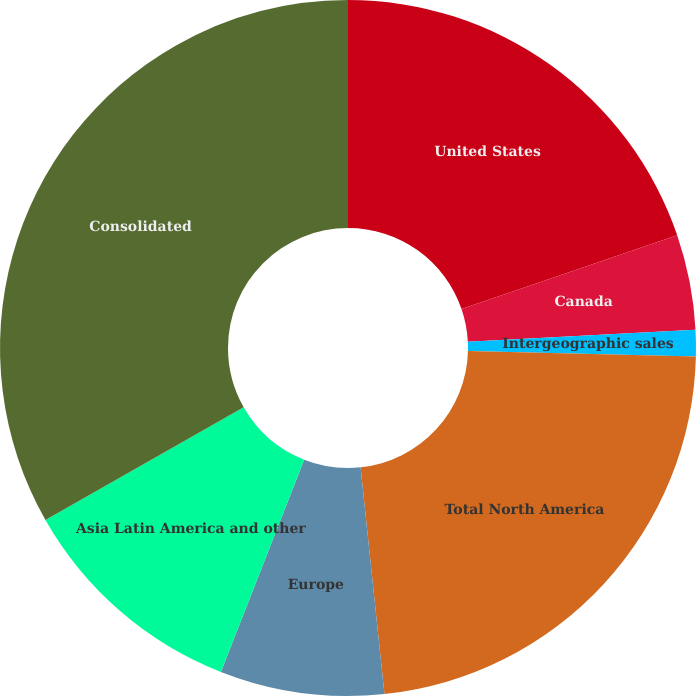Convert chart. <chart><loc_0><loc_0><loc_500><loc_500><pie_chart><fcel>United States<fcel>Canada<fcel>Intergeographic sales<fcel>Total North America<fcel>Europe<fcel>Asia Latin America and other<fcel>Consolidated<nl><fcel>19.74%<fcel>4.42%<fcel>1.22%<fcel>22.94%<fcel>7.62%<fcel>10.82%<fcel>33.22%<nl></chart> 